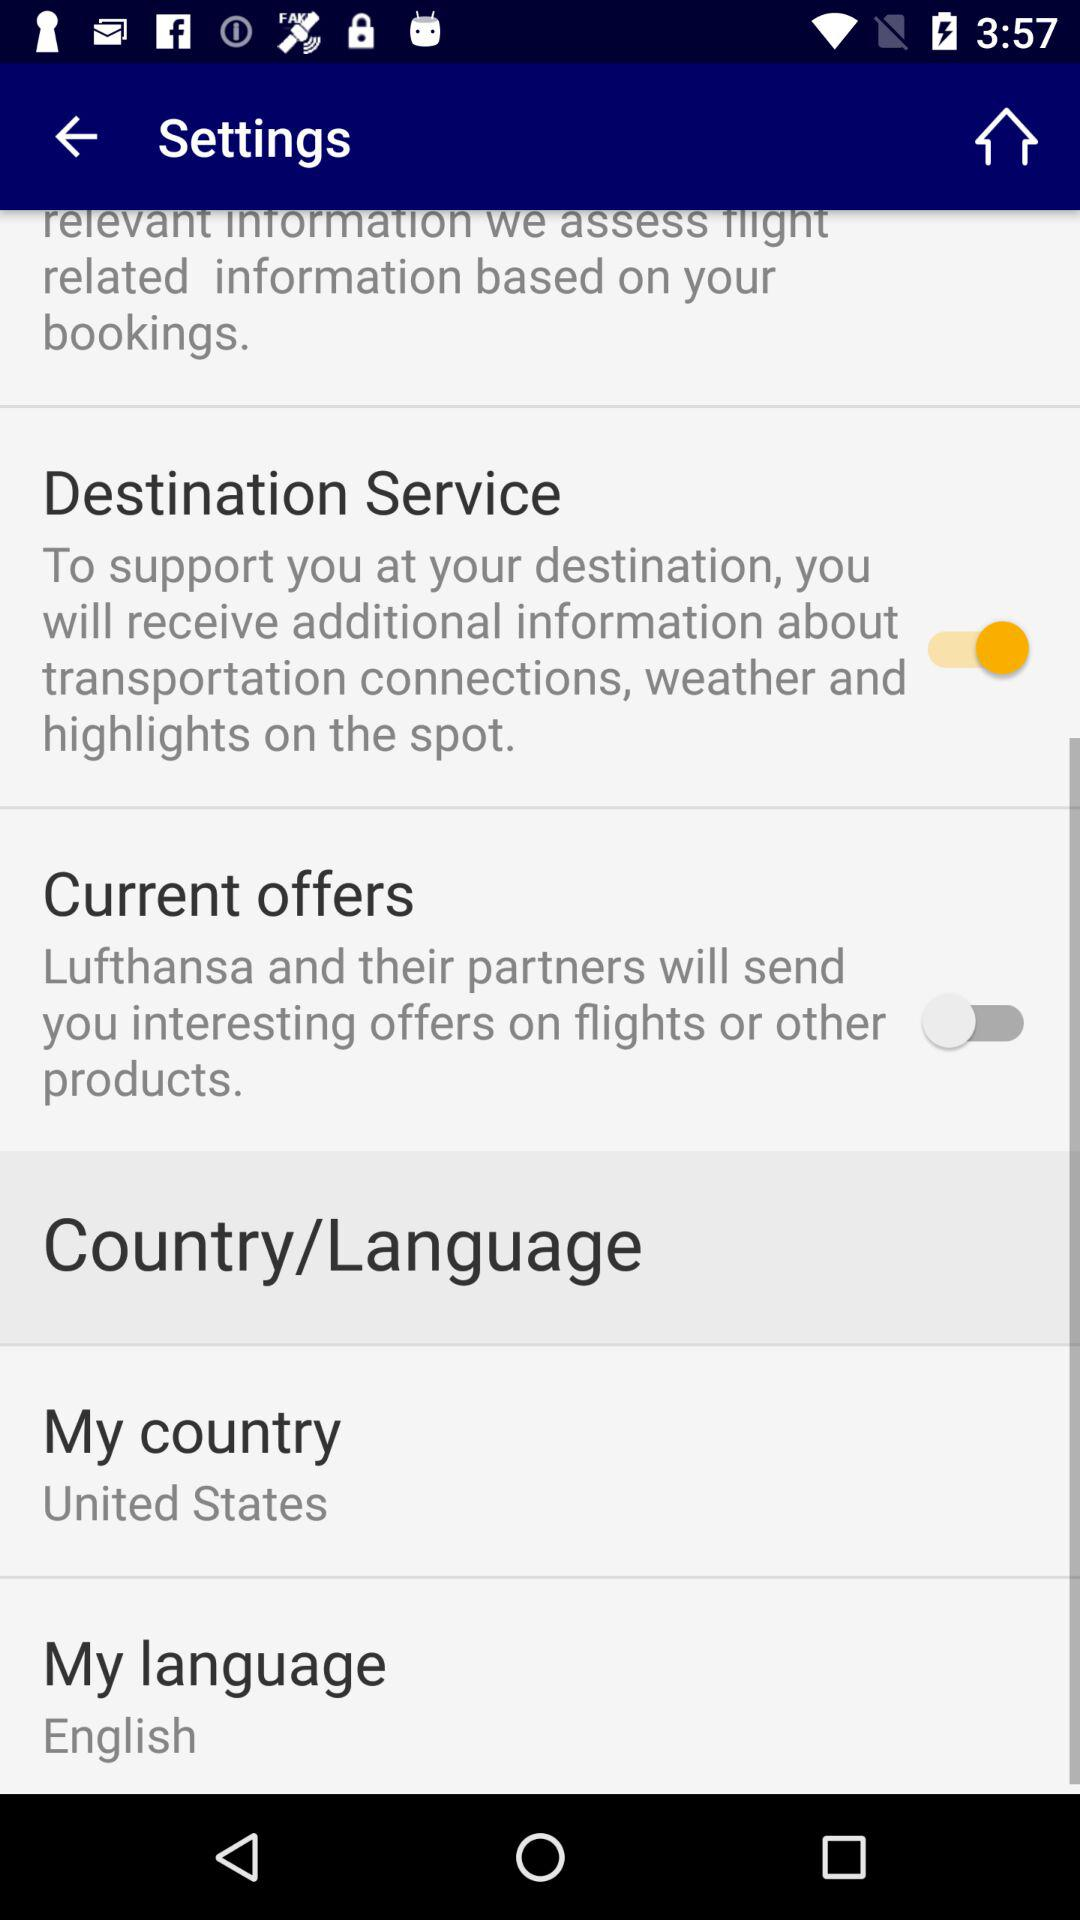What is the selected country? The selected country is the "United States". 